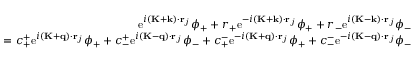Convert formula to latex. <formula><loc_0><loc_0><loc_500><loc_500>\begin{array} { r } { e ^ { i ( K + k ) \cdot r _ { j } } \phi _ { + } + r _ { + } e ^ { - i ( K + k ) \cdot r _ { j } } \phi _ { + } + r _ { - } e ^ { i ( K - k ) \cdot r _ { j } } \phi _ { - } } \\ { = c _ { + } ^ { + } e ^ { i ( K + q ) \cdot r _ { j } } \phi _ { + } + c _ { - } ^ { + } e ^ { i ( K - q ) \cdot r _ { j } } \phi _ { - } + c _ { + } ^ { - } e ^ { - i ( K + q ) \cdot r _ { j } } \phi _ { + } + c _ { - } ^ { - } e ^ { - i ( K - q ) \cdot r _ { j } } \phi _ { - } } \end{array}</formula> 